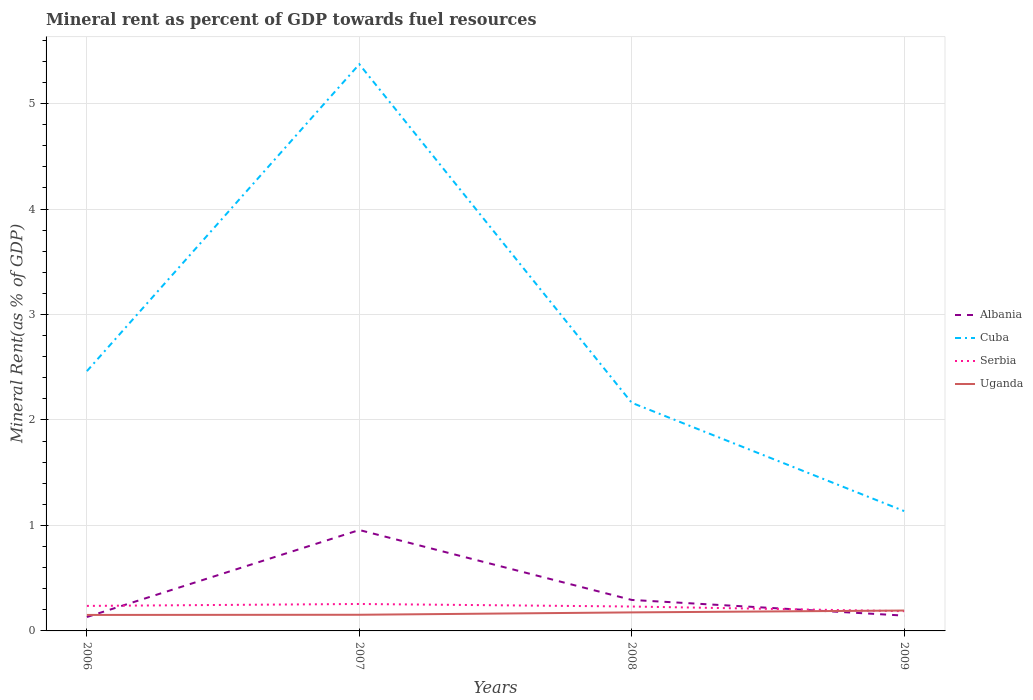How many different coloured lines are there?
Your response must be concise. 4. Across all years, what is the maximum mineral rent in Serbia?
Keep it short and to the point. 0.19. What is the total mineral rent in Serbia in the graph?
Your answer should be compact. 0.04. What is the difference between the highest and the second highest mineral rent in Albania?
Make the answer very short. 0.82. What is the difference between the highest and the lowest mineral rent in Uganda?
Your response must be concise. 2. Does the graph contain any zero values?
Ensure brevity in your answer.  No. Where does the legend appear in the graph?
Your answer should be very brief. Center right. How many legend labels are there?
Your response must be concise. 4. How are the legend labels stacked?
Keep it short and to the point. Vertical. What is the title of the graph?
Keep it short and to the point. Mineral rent as percent of GDP towards fuel resources. What is the label or title of the X-axis?
Give a very brief answer. Years. What is the label or title of the Y-axis?
Give a very brief answer. Mineral Rent(as % of GDP). What is the Mineral Rent(as % of GDP) in Albania in 2006?
Make the answer very short. 0.13. What is the Mineral Rent(as % of GDP) in Cuba in 2006?
Give a very brief answer. 2.46. What is the Mineral Rent(as % of GDP) in Serbia in 2006?
Provide a short and direct response. 0.24. What is the Mineral Rent(as % of GDP) in Uganda in 2006?
Keep it short and to the point. 0.15. What is the Mineral Rent(as % of GDP) of Albania in 2007?
Keep it short and to the point. 0.96. What is the Mineral Rent(as % of GDP) of Cuba in 2007?
Make the answer very short. 5.37. What is the Mineral Rent(as % of GDP) of Serbia in 2007?
Provide a short and direct response. 0.26. What is the Mineral Rent(as % of GDP) in Uganda in 2007?
Keep it short and to the point. 0.15. What is the Mineral Rent(as % of GDP) of Albania in 2008?
Offer a terse response. 0.29. What is the Mineral Rent(as % of GDP) in Cuba in 2008?
Give a very brief answer. 2.16. What is the Mineral Rent(as % of GDP) of Serbia in 2008?
Your answer should be very brief. 0.23. What is the Mineral Rent(as % of GDP) in Uganda in 2008?
Offer a very short reply. 0.18. What is the Mineral Rent(as % of GDP) of Albania in 2009?
Give a very brief answer. 0.15. What is the Mineral Rent(as % of GDP) of Cuba in 2009?
Offer a very short reply. 1.14. What is the Mineral Rent(as % of GDP) of Serbia in 2009?
Make the answer very short. 0.19. What is the Mineral Rent(as % of GDP) in Uganda in 2009?
Make the answer very short. 0.19. Across all years, what is the maximum Mineral Rent(as % of GDP) in Albania?
Make the answer very short. 0.96. Across all years, what is the maximum Mineral Rent(as % of GDP) in Cuba?
Offer a very short reply. 5.37. Across all years, what is the maximum Mineral Rent(as % of GDP) in Serbia?
Provide a short and direct response. 0.26. Across all years, what is the maximum Mineral Rent(as % of GDP) in Uganda?
Ensure brevity in your answer.  0.19. Across all years, what is the minimum Mineral Rent(as % of GDP) in Albania?
Make the answer very short. 0.13. Across all years, what is the minimum Mineral Rent(as % of GDP) in Cuba?
Your answer should be compact. 1.14. Across all years, what is the minimum Mineral Rent(as % of GDP) in Serbia?
Make the answer very short. 0.19. Across all years, what is the minimum Mineral Rent(as % of GDP) of Uganda?
Your response must be concise. 0.15. What is the total Mineral Rent(as % of GDP) of Albania in the graph?
Your response must be concise. 1.53. What is the total Mineral Rent(as % of GDP) of Cuba in the graph?
Give a very brief answer. 11.14. What is the total Mineral Rent(as % of GDP) of Serbia in the graph?
Make the answer very short. 0.91. What is the total Mineral Rent(as % of GDP) in Uganda in the graph?
Offer a terse response. 0.67. What is the difference between the Mineral Rent(as % of GDP) in Albania in 2006 and that in 2007?
Your answer should be very brief. -0.82. What is the difference between the Mineral Rent(as % of GDP) of Cuba in 2006 and that in 2007?
Give a very brief answer. -2.91. What is the difference between the Mineral Rent(as % of GDP) of Serbia in 2006 and that in 2007?
Your response must be concise. -0.02. What is the difference between the Mineral Rent(as % of GDP) in Uganda in 2006 and that in 2007?
Offer a terse response. -0. What is the difference between the Mineral Rent(as % of GDP) in Albania in 2006 and that in 2008?
Provide a short and direct response. -0.16. What is the difference between the Mineral Rent(as % of GDP) in Cuba in 2006 and that in 2008?
Your answer should be compact. 0.3. What is the difference between the Mineral Rent(as % of GDP) in Serbia in 2006 and that in 2008?
Provide a succinct answer. 0.01. What is the difference between the Mineral Rent(as % of GDP) in Uganda in 2006 and that in 2008?
Provide a short and direct response. -0.02. What is the difference between the Mineral Rent(as % of GDP) in Albania in 2006 and that in 2009?
Provide a short and direct response. -0.01. What is the difference between the Mineral Rent(as % of GDP) in Cuba in 2006 and that in 2009?
Offer a terse response. 1.33. What is the difference between the Mineral Rent(as % of GDP) of Serbia in 2006 and that in 2009?
Your answer should be compact. 0.05. What is the difference between the Mineral Rent(as % of GDP) of Uganda in 2006 and that in 2009?
Keep it short and to the point. -0.04. What is the difference between the Mineral Rent(as % of GDP) in Albania in 2007 and that in 2008?
Offer a terse response. 0.66. What is the difference between the Mineral Rent(as % of GDP) of Cuba in 2007 and that in 2008?
Ensure brevity in your answer.  3.21. What is the difference between the Mineral Rent(as % of GDP) of Serbia in 2007 and that in 2008?
Provide a short and direct response. 0.02. What is the difference between the Mineral Rent(as % of GDP) of Uganda in 2007 and that in 2008?
Give a very brief answer. -0.02. What is the difference between the Mineral Rent(as % of GDP) in Albania in 2007 and that in 2009?
Keep it short and to the point. 0.81. What is the difference between the Mineral Rent(as % of GDP) of Cuba in 2007 and that in 2009?
Keep it short and to the point. 4.24. What is the difference between the Mineral Rent(as % of GDP) of Serbia in 2007 and that in 2009?
Offer a very short reply. 0.07. What is the difference between the Mineral Rent(as % of GDP) of Uganda in 2007 and that in 2009?
Your answer should be compact. -0.04. What is the difference between the Mineral Rent(as % of GDP) in Albania in 2008 and that in 2009?
Provide a succinct answer. 0.15. What is the difference between the Mineral Rent(as % of GDP) in Cuba in 2008 and that in 2009?
Provide a succinct answer. 1.03. What is the difference between the Mineral Rent(as % of GDP) of Serbia in 2008 and that in 2009?
Keep it short and to the point. 0.04. What is the difference between the Mineral Rent(as % of GDP) of Uganda in 2008 and that in 2009?
Make the answer very short. -0.02. What is the difference between the Mineral Rent(as % of GDP) of Albania in 2006 and the Mineral Rent(as % of GDP) of Cuba in 2007?
Your response must be concise. -5.24. What is the difference between the Mineral Rent(as % of GDP) in Albania in 2006 and the Mineral Rent(as % of GDP) in Serbia in 2007?
Offer a terse response. -0.12. What is the difference between the Mineral Rent(as % of GDP) of Albania in 2006 and the Mineral Rent(as % of GDP) of Uganda in 2007?
Offer a terse response. -0.02. What is the difference between the Mineral Rent(as % of GDP) in Cuba in 2006 and the Mineral Rent(as % of GDP) in Serbia in 2007?
Your answer should be very brief. 2.21. What is the difference between the Mineral Rent(as % of GDP) of Cuba in 2006 and the Mineral Rent(as % of GDP) of Uganda in 2007?
Provide a succinct answer. 2.31. What is the difference between the Mineral Rent(as % of GDP) in Serbia in 2006 and the Mineral Rent(as % of GDP) in Uganda in 2007?
Provide a succinct answer. 0.08. What is the difference between the Mineral Rent(as % of GDP) in Albania in 2006 and the Mineral Rent(as % of GDP) in Cuba in 2008?
Provide a succinct answer. -2.03. What is the difference between the Mineral Rent(as % of GDP) in Albania in 2006 and the Mineral Rent(as % of GDP) in Serbia in 2008?
Your answer should be compact. -0.1. What is the difference between the Mineral Rent(as % of GDP) in Albania in 2006 and the Mineral Rent(as % of GDP) in Uganda in 2008?
Your answer should be compact. -0.04. What is the difference between the Mineral Rent(as % of GDP) of Cuba in 2006 and the Mineral Rent(as % of GDP) of Serbia in 2008?
Make the answer very short. 2.23. What is the difference between the Mineral Rent(as % of GDP) in Cuba in 2006 and the Mineral Rent(as % of GDP) in Uganda in 2008?
Make the answer very short. 2.29. What is the difference between the Mineral Rent(as % of GDP) in Serbia in 2006 and the Mineral Rent(as % of GDP) in Uganda in 2008?
Offer a very short reply. 0.06. What is the difference between the Mineral Rent(as % of GDP) in Albania in 2006 and the Mineral Rent(as % of GDP) in Cuba in 2009?
Make the answer very short. -1. What is the difference between the Mineral Rent(as % of GDP) in Albania in 2006 and the Mineral Rent(as % of GDP) in Serbia in 2009?
Offer a terse response. -0.06. What is the difference between the Mineral Rent(as % of GDP) of Albania in 2006 and the Mineral Rent(as % of GDP) of Uganda in 2009?
Keep it short and to the point. -0.06. What is the difference between the Mineral Rent(as % of GDP) in Cuba in 2006 and the Mineral Rent(as % of GDP) in Serbia in 2009?
Make the answer very short. 2.28. What is the difference between the Mineral Rent(as % of GDP) of Cuba in 2006 and the Mineral Rent(as % of GDP) of Uganda in 2009?
Ensure brevity in your answer.  2.27. What is the difference between the Mineral Rent(as % of GDP) in Serbia in 2006 and the Mineral Rent(as % of GDP) in Uganda in 2009?
Give a very brief answer. 0.04. What is the difference between the Mineral Rent(as % of GDP) in Albania in 2007 and the Mineral Rent(as % of GDP) in Cuba in 2008?
Your answer should be compact. -1.21. What is the difference between the Mineral Rent(as % of GDP) of Albania in 2007 and the Mineral Rent(as % of GDP) of Serbia in 2008?
Provide a short and direct response. 0.73. What is the difference between the Mineral Rent(as % of GDP) of Albania in 2007 and the Mineral Rent(as % of GDP) of Uganda in 2008?
Your answer should be compact. 0.78. What is the difference between the Mineral Rent(as % of GDP) in Cuba in 2007 and the Mineral Rent(as % of GDP) in Serbia in 2008?
Give a very brief answer. 5.14. What is the difference between the Mineral Rent(as % of GDP) of Cuba in 2007 and the Mineral Rent(as % of GDP) of Uganda in 2008?
Offer a very short reply. 5.2. What is the difference between the Mineral Rent(as % of GDP) in Serbia in 2007 and the Mineral Rent(as % of GDP) in Uganda in 2008?
Provide a short and direct response. 0.08. What is the difference between the Mineral Rent(as % of GDP) of Albania in 2007 and the Mineral Rent(as % of GDP) of Cuba in 2009?
Ensure brevity in your answer.  -0.18. What is the difference between the Mineral Rent(as % of GDP) in Albania in 2007 and the Mineral Rent(as % of GDP) in Serbia in 2009?
Give a very brief answer. 0.77. What is the difference between the Mineral Rent(as % of GDP) in Albania in 2007 and the Mineral Rent(as % of GDP) in Uganda in 2009?
Offer a terse response. 0.76. What is the difference between the Mineral Rent(as % of GDP) in Cuba in 2007 and the Mineral Rent(as % of GDP) in Serbia in 2009?
Your response must be concise. 5.19. What is the difference between the Mineral Rent(as % of GDP) of Cuba in 2007 and the Mineral Rent(as % of GDP) of Uganda in 2009?
Offer a terse response. 5.18. What is the difference between the Mineral Rent(as % of GDP) of Serbia in 2007 and the Mineral Rent(as % of GDP) of Uganda in 2009?
Keep it short and to the point. 0.06. What is the difference between the Mineral Rent(as % of GDP) in Albania in 2008 and the Mineral Rent(as % of GDP) in Cuba in 2009?
Your response must be concise. -0.84. What is the difference between the Mineral Rent(as % of GDP) of Albania in 2008 and the Mineral Rent(as % of GDP) of Serbia in 2009?
Your answer should be compact. 0.11. What is the difference between the Mineral Rent(as % of GDP) of Albania in 2008 and the Mineral Rent(as % of GDP) of Uganda in 2009?
Give a very brief answer. 0.1. What is the difference between the Mineral Rent(as % of GDP) in Cuba in 2008 and the Mineral Rent(as % of GDP) in Serbia in 2009?
Give a very brief answer. 1.98. What is the difference between the Mineral Rent(as % of GDP) in Cuba in 2008 and the Mineral Rent(as % of GDP) in Uganda in 2009?
Ensure brevity in your answer.  1.97. What is the difference between the Mineral Rent(as % of GDP) of Serbia in 2008 and the Mineral Rent(as % of GDP) of Uganda in 2009?
Your answer should be compact. 0.04. What is the average Mineral Rent(as % of GDP) in Albania per year?
Ensure brevity in your answer.  0.38. What is the average Mineral Rent(as % of GDP) in Cuba per year?
Offer a very short reply. 2.78. What is the average Mineral Rent(as % of GDP) in Serbia per year?
Ensure brevity in your answer.  0.23. What is the average Mineral Rent(as % of GDP) in Uganda per year?
Provide a short and direct response. 0.17. In the year 2006, what is the difference between the Mineral Rent(as % of GDP) in Albania and Mineral Rent(as % of GDP) in Cuba?
Offer a very short reply. -2.33. In the year 2006, what is the difference between the Mineral Rent(as % of GDP) in Albania and Mineral Rent(as % of GDP) in Serbia?
Your answer should be very brief. -0.11. In the year 2006, what is the difference between the Mineral Rent(as % of GDP) in Albania and Mineral Rent(as % of GDP) in Uganda?
Make the answer very short. -0.02. In the year 2006, what is the difference between the Mineral Rent(as % of GDP) in Cuba and Mineral Rent(as % of GDP) in Serbia?
Give a very brief answer. 2.23. In the year 2006, what is the difference between the Mineral Rent(as % of GDP) in Cuba and Mineral Rent(as % of GDP) in Uganda?
Your response must be concise. 2.31. In the year 2006, what is the difference between the Mineral Rent(as % of GDP) in Serbia and Mineral Rent(as % of GDP) in Uganda?
Give a very brief answer. 0.09. In the year 2007, what is the difference between the Mineral Rent(as % of GDP) of Albania and Mineral Rent(as % of GDP) of Cuba?
Provide a succinct answer. -4.42. In the year 2007, what is the difference between the Mineral Rent(as % of GDP) in Albania and Mineral Rent(as % of GDP) in Serbia?
Offer a terse response. 0.7. In the year 2007, what is the difference between the Mineral Rent(as % of GDP) of Albania and Mineral Rent(as % of GDP) of Uganda?
Provide a succinct answer. 0.8. In the year 2007, what is the difference between the Mineral Rent(as % of GDP) of Cuba and Mineral Rent(as % of GDP) of Serbia?
Make the answer very short. 5.12. In the year 2007, what is the difference between the Mineral Rent(as % of GDP) in Cuba and Mineral Rent(as % of GDP) in Uganda?
Offer a very short reply. 5.22. In the year 2007, what is the difference between the Mineral Rent(as % of GDP) in Serbia and Mineral Rent(as % of GDP) in Uganda?
Ensure brevity in your answer.  0.1. In the year 2008, what is the difference between the Mineral Rent(as % of GDP) of Albania and Mineral Rent(as % of GDP) of Cuba?
Offer a very short reply. -1.87. In the year 2008, what is the difference between the Mineral Rent(as % of GDP) of Albania and Mineral Rent(as % of GDP) of Serbia?
Offer a very short reply. 0.06. In the year 2008, what is the difference between the Mineral Rent(as % of GDP) in Albania and Mineral Rent(as % of GDP) in Uganda?
Your answer should be compact. 0.12. In the year 2008, what is the difference between the Mineral Rent(as % of GDP) in Cuba and Mineral Rent(as % of GDP) in Serbia?
Your answer should be compact. 1.93. In the year 2008, what is the difference between the Mineral Rent(as % of GDP) of Cuba and Mineral Rent(as % of GDP) of Uganda?
Offer a terse response. 1.99. In the year 2008, what is the difference between the Mineral Rent(as % of GDP) in Serbia and Mineral Rent(as % of GDP) in Uganda?
Make the answer very short. 0.06. In the year 2009, what is the difference between the Mineral Rent(as % of GDP) in Albania and Mineral Rent(as % of GDP) in Cuba?
Your answer should be compact. -0.99. In the year 2009, what is the difference between the Mineral Rent(as % of GDP) of Albania and Mineral Rent(as % of GDP) of Serbia?
Your response must be concise. -0.04. In the year 2009, what is the difference between the Mineral Rent(as % of GDP) of Albania and Mineral Rent(as % of GDP) of Uganda?
Ensure brevity in your answer.  -0.05. In the year 2009, what is the difference between the Mineral Rent(as % of GDP) in Cuba and Mineral Rent(as % of GDP) in Serbia?
Your response must be concise. 0.95. In the year 2009, what is the difference between the Mineral Rent(as % of GDP) in Cuba and Mineral Rent(as % of GDP) in Uganda?
Give a very brief answer. 0.94. In the year 2009, what is the difference between the Mineral Rent(as % of GDP) of Serbia and Mineral Rent(as % of GDP) of Uganda?
Offer a terse response. -0.01. What is the ratio of the Mineral Rent(as % of GDP) in Albania in 2006 to that in 2007?
Your answer should be compact. 0.14. What is the ratio of the Mineral Rent(as % of GDP) in Cuba in 2006 to that in 2007?
Offer a very short reply. 0.46. What is the ratio of the Mineral Rent(as % of GDP) in Uganda in 2006 to that in 2007?
Keep it short and to the point. 0.99. What is the ratio of the Mineral Rent(as % of GDP) in Albania in 2006 to that in 2008?
Offer a very short reply. 0.45. What is the ratio of the Mineral Rent(as % of GDP) of Cuba in 2006 to that in 2008?
Your response must be concise. 1.14. What is the ratio of the Mineral Rent(as % of GDP) of Serbia in 2006 to that in 2008?
Your response must be concise. 1.02. What is the ratio of the Mineral Rent(as % of GDP) in Uganda in 2006 to that in 2008?
Offer a very short reply. 0.86. What is the ratio of the Mineral Rent(as % of GDP) in Albania in 2006 to that in 2009?
Your response must be concise. 0.91. What is the ratio of the Mineral Rent(as % of GDP) in Cuba in 2006 to that in 2009?
Ensure brevity in your answer.  2.17. What is the ratio of the Mineral Rent(as % of GDP) in Serbia in 2006 to that in 2009?
Your answer should be very brief. 1.27. What is the ratio of the Mineral Rent(as % of GDP) in Uganda in 2006 to that in 2009?
Ensure brevity in your answer.  0.78. What is the ratio of the Mineral Rent(as % of GDP) in Albania in 2007 to that in 2008?
Offer a very short reply. 3.26. What is the ratio of the Mineral Rent(as % of GDP) in Cuba in 2007 to that in 2008?
Make the answer very short. 2.48. What is the ratio of the Mineral Rent(as % of GDP) of Serbia in 2007 to that in 2008?
Give a very brief answer. 1.1. What is the ratio of the Mineral Rent(as % of GDP) of Uganda in 2007 to that in 2008?
Provide a succinct answer. 0.87. What is the ratio of the Mineral Rent(as % of GDP) of Albania in 2007 to that in 2009?
Keep it short and to the point. 6.59. What is the ratio of the Mineral Rent(as % of GDP) of Cuba in 2007 to that in 2009?
Offer a very short reply. 4.73. What is the ratio of the Mineral Rent(as % of GDP) of Serbia in 2007 to that in 2009?
Offer a very short reply. 1.37. What is the ratio of the Mineral Rent(as % of GDP) in Uganda in 2007 to that in 2009?
Your answer should be very brief. 0.79. What is the ratio of the Mineral Rent(as % of GDP) of Albania in 2008 to that in 2009?
Provide a short and direct response. 2.02. What is the ratio of the Mineral Rent(as % of GDP) in Cuba in 2008 to that in 2009?
Ensure brevity in your answer.  1.9. What is the ratio of the Mineral Rent(as % of GDP) of Serbia in 2008 to that in 2009?
Your response must be concise. 1.24. What is the ratio of the Mineral Rent(as % of GDP) of Uganda in 2008 to that in 2009?
Your response must be concise. 0.91. What is the difference between the highest and the second highest Mineral Rent(as % of GDP) of Albania?
Ensure brevity in your answer.  0.66. What is the difference between the highest and the second highest Mineral Rent(as % of GDP) of Cuba?
Your answer should be very brief. 2.91. What is the difference between the highest and the second highest Mineral Rent(as % of GDP) of Serbia?
Keep it short and to the point. 0.02. What is the difference between the highest and the second highest Mineral Rent(as % of GDP) of Uganda?
Offer a very short reply. 0.02. What is the difference between the highest and the lowest Mineral Rent(as % of GDP) of Albania?
Offer a very short reply. 0.82. What is the difference between the highest and the lowest Mineral Rent(as % of GDP) of Cuba?
Give a very brief answer. 4.24. What is the difference between the highest and the lowest Mineral Rent(as % of GDP) in Serbia?
Provide a succinct answer. 0.07. What is the difference between the highest and the lowest Mineral Rent(as % of GDP) of Uganda?
Your response must be concise. 0.04. 